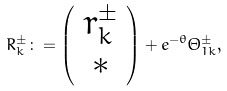<formula> <loc_0><loc_0><loc_500><loc_500>R _ { k } ^ { \pm } \colon = \left ( \begin{array} { c } r _ { k } ^ { \pm } \\ * \end{array} \right ) + e ^ { - \theta } \Theta _ { 1 k } ^ { \pm } ,</formula> 